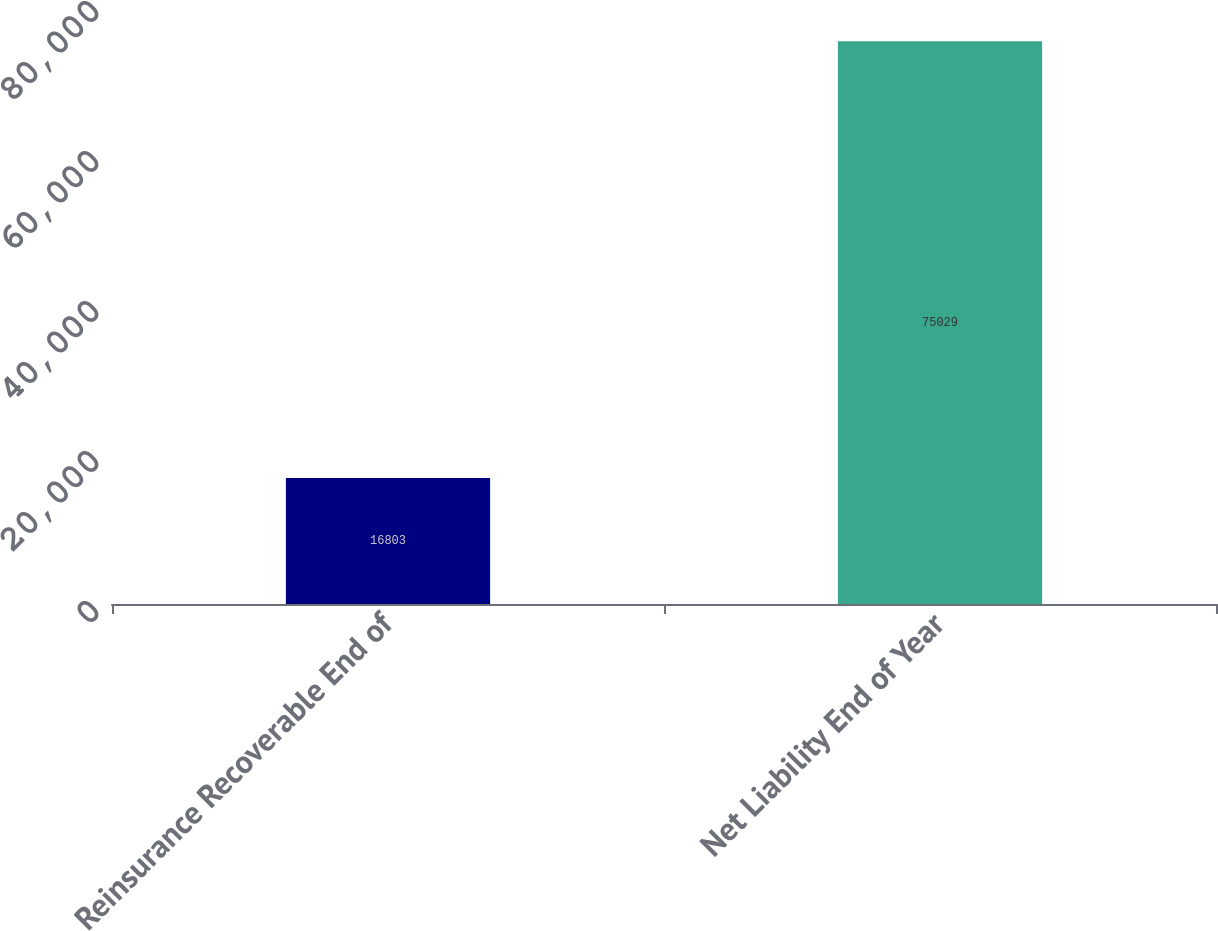Convert chart to OTSL. <chart><loc_0><loc_0><loc_500><loc_500><bar_chart><fcel>Reinsurance Recoverable End of<fcel>Net Liability End of Year<nl><fcel>16803<fcel>75029<nl></chart> 